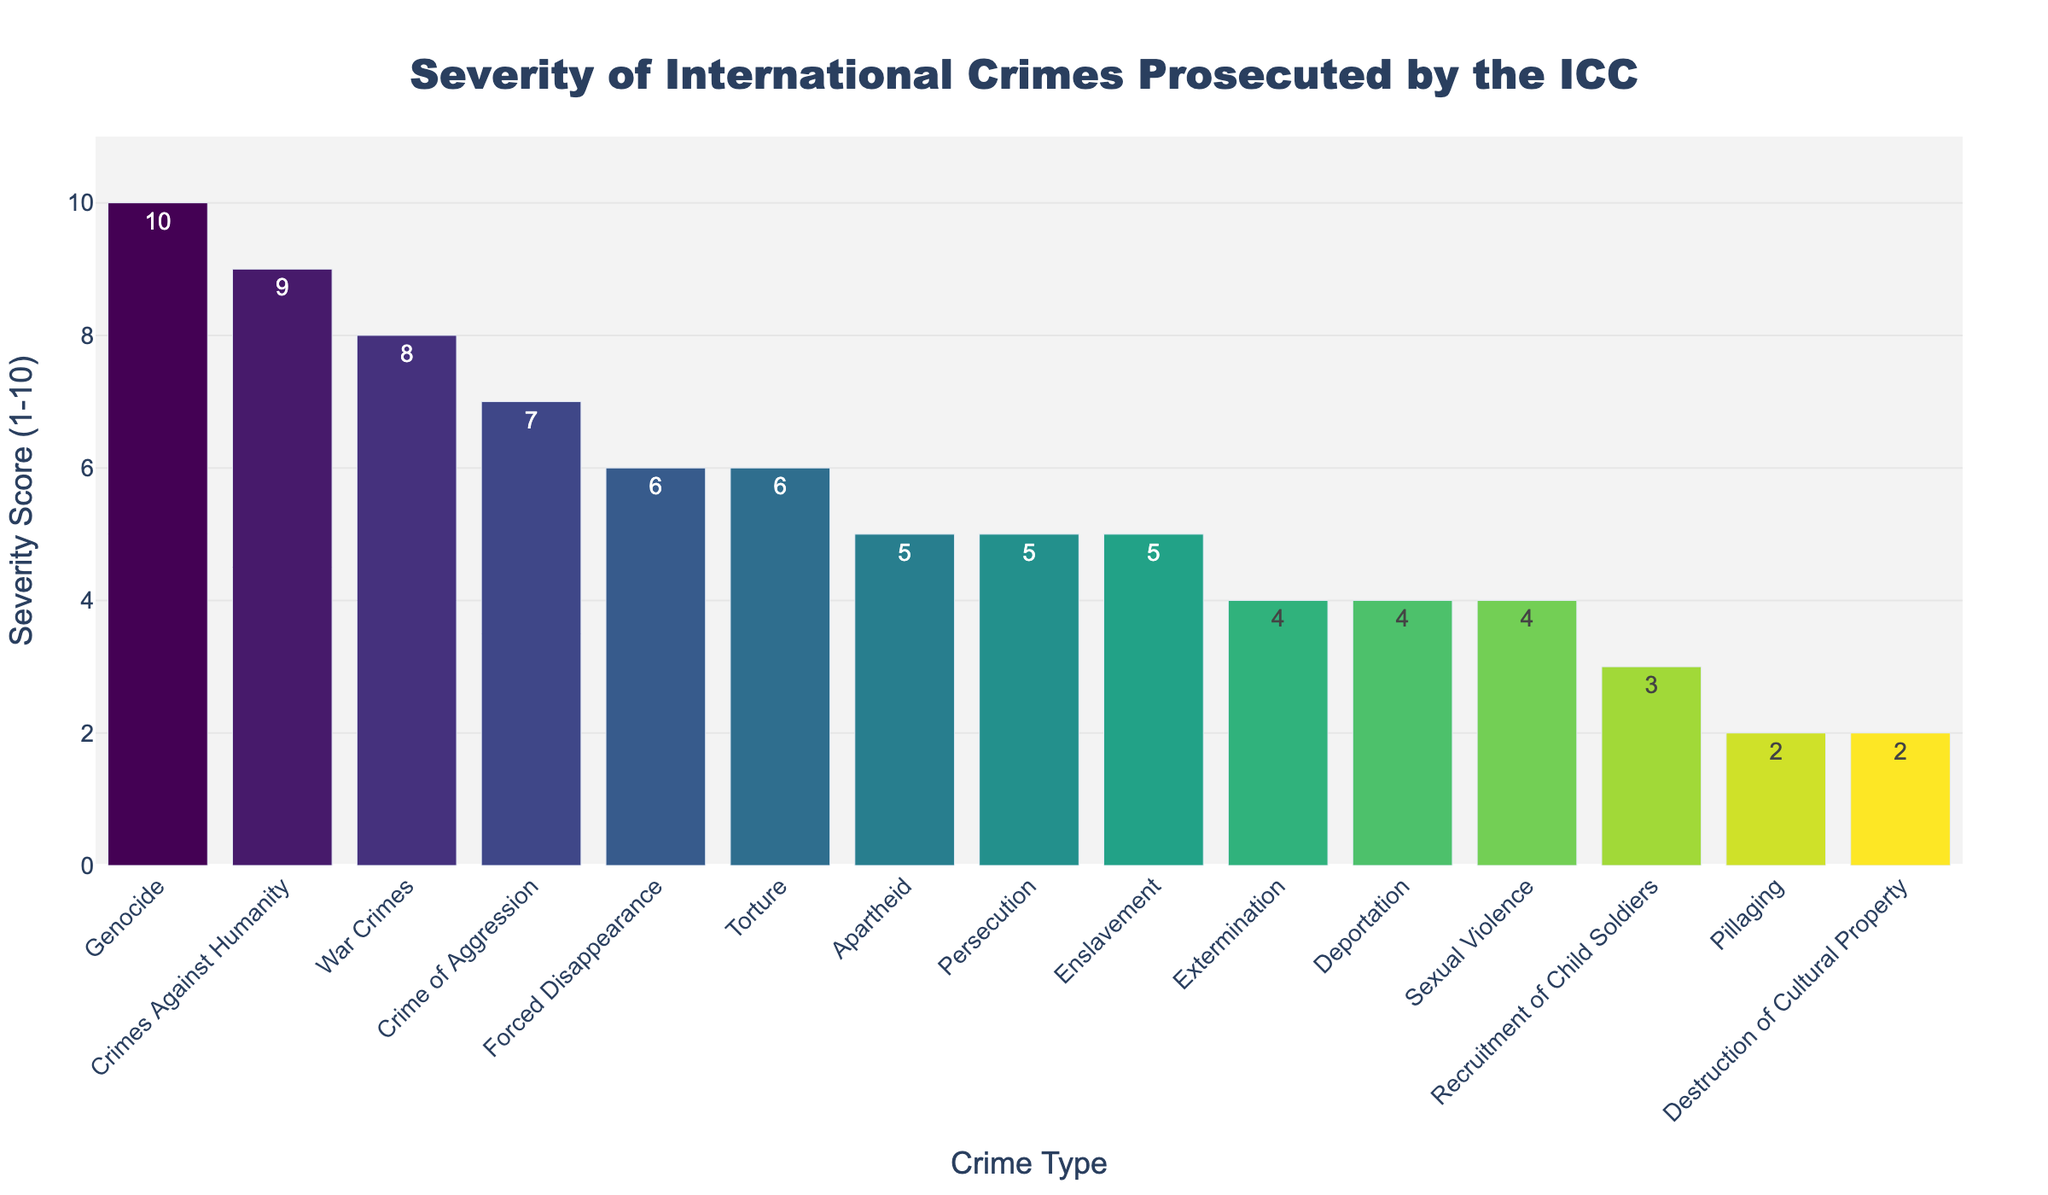Which crime type has the highest severity score? The figure shows that "Genocide" has the tallest bar, representing the highest severity score.
Answer: Genocide Which crime type has the lowest severity score? The figure shows that "Pillaging" and "Destruction of Cultural Property" have the shortest bars, both representing the lowest severity score of 2.
Answer: Pillaging, Destruction of Cultural Property What is the difference in severity score between "Genocide" and "War Crimes"? The severity score for "Genocide" is 10 and for "War Crimes" is 8. The difference is calculated as 10 - 8.
Answer: 2 Which three crime types have a severity score of 5? The figure shows three bars with a severity score of 5: "Apartheid," "Persecution," and "Enslavement".
Answer: Apartheid, Persecution, Enslavement What is the average severity score of "Genocide," "Crimes Against Humanity," and "War Crimes"? The severity scores are 10 for "Genocide," 9 for "Crimes Against Humanity," and 8 for "War Crimes." Summing these values gives 27, and dividing by the number of crimes (3) gives 27/3.
Answer: 9 Which crime type has a severity score of 4 and appears second from the last on the x-axis? The figure's x-axis shows "Sexual Violence" second to the last with a severity score of 4.
Answer: Sexual Violence Is the severity score of "Forced Disappearance" greater than "Recruitment of Child Soldiers"? If so, by how much? "Forced Disappearance" has a severity score of 6, which is greater than "Recruitment of Child Soldiers" with a score of 3. The difference is 6 - 3.
Answer: Yes, by 3 How many crime types have a severity score equal to or greater than 6? The bars representing scores 6 and above are "Genocide," "Crimes Against Humanity," "War Crimes," "Crime of Aggression," "Forced Disappearance," and "Torture," totaling 6 crime types.
Answer: 6 Which crime type with a severity score of 5 appears first on the x-axis? The figure shows "Apartheid" as the first type with a severity score of 5 on the x-axis.
Answer: Apartheid 